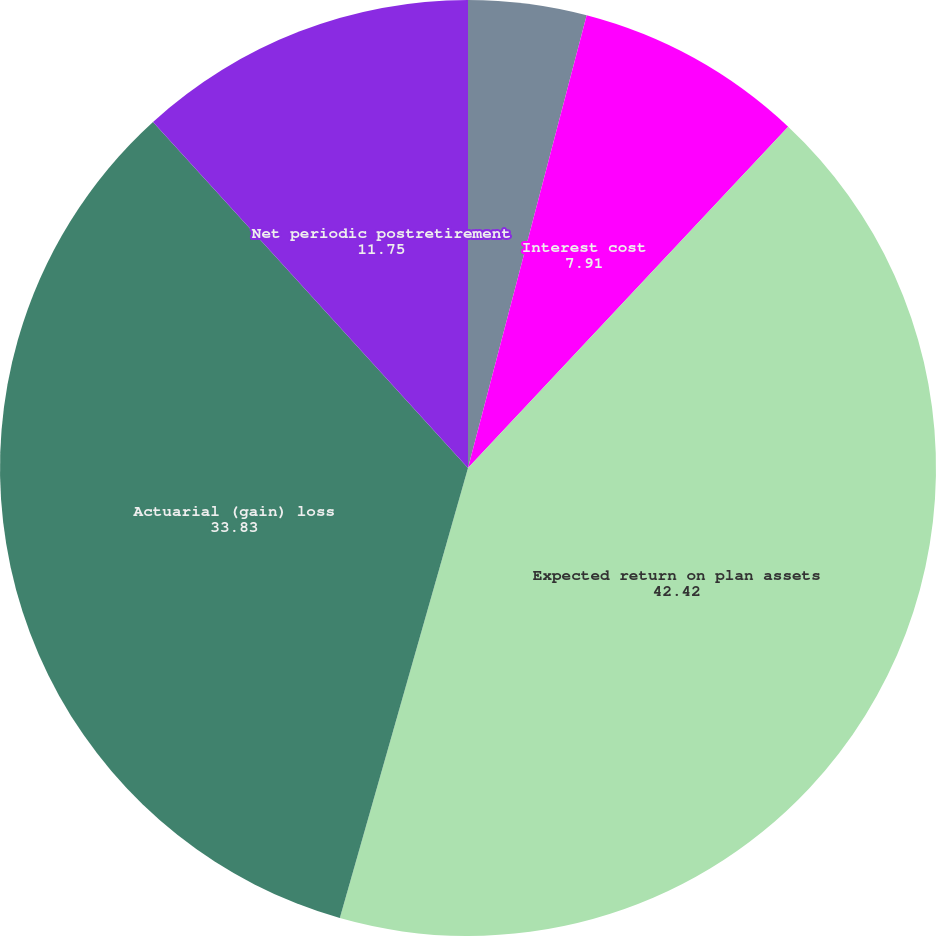Convert chart. <chart><loc_0><loc_0><loc_500><loc_500><pie_chart><fcel>Service cost<fcel>Interest cost<fcel>Expected return on plan assets<fcel>Actuarial (gain) loss<fcel>Net periodic postretirement<nl><fcel>4.08%<fcel>7.91%<fcel>42.42%<fcel>33.83%<fcel>11.75%<nl></chart> 